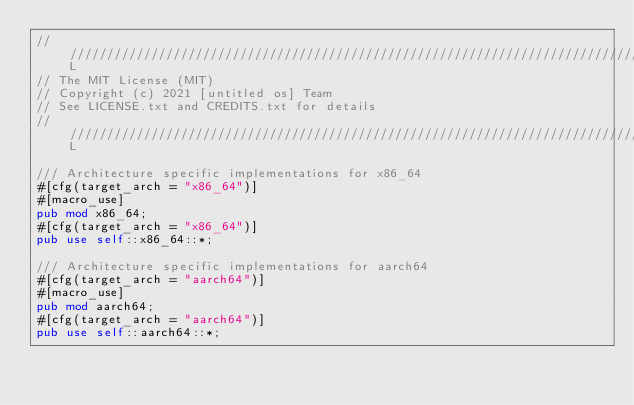Convert code to text. <code><loc_0><loc_0><loc_500><loc_500><_Rust_>///////////////////////////////////////////////////////////////////////////////L
// The MIT License (MIT)
// Copyright (c) 2021 [untitled os] Team
// See LICENSE.txt and CREDITS.txt for details
///////////////////////////////////////////////////////////////////////////////L

/// Architecture specific implementations for x86_64
#[cfg(target_arch = "x86_64")]
#[macro_use]
pub mod x86_64;
#[cfg(target_arch = "x86_64")]
pub use self::x86_64::*;

/// Architecture specific implementations for aarch64
#[cfg(target_arch = "aarch64")]
#[macro_use]
pub mod aarch64;
#[cfg(target_arch = "aarch64")]
pub use self::aarch64::*;
</code> 